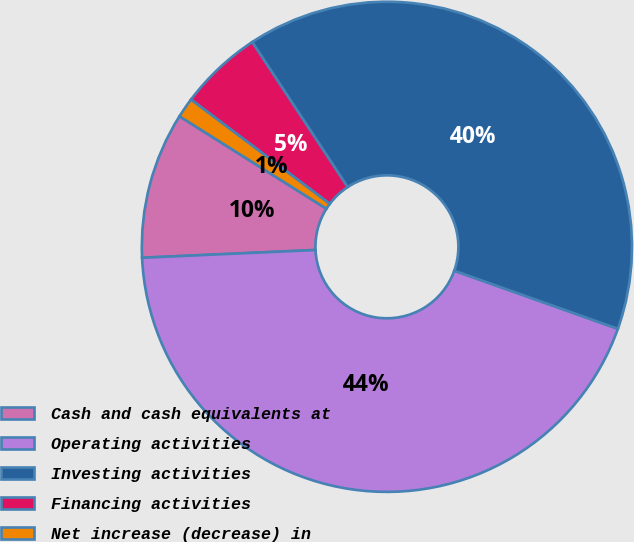Convert chart. <chart><loc_0><loc_0><loc_500><loc_500><pie_chart><fcel>Cash and cash equivalents at<fcel>Operating activities<fcel>Investing activities<fcel>Financing activities<fcel>Net increase (decrease) in<nl><fcel>9.65%<fcel>43.86%<fcel>39.69%<fcel>5.48%<fcel>1.32%<nl></chart> 